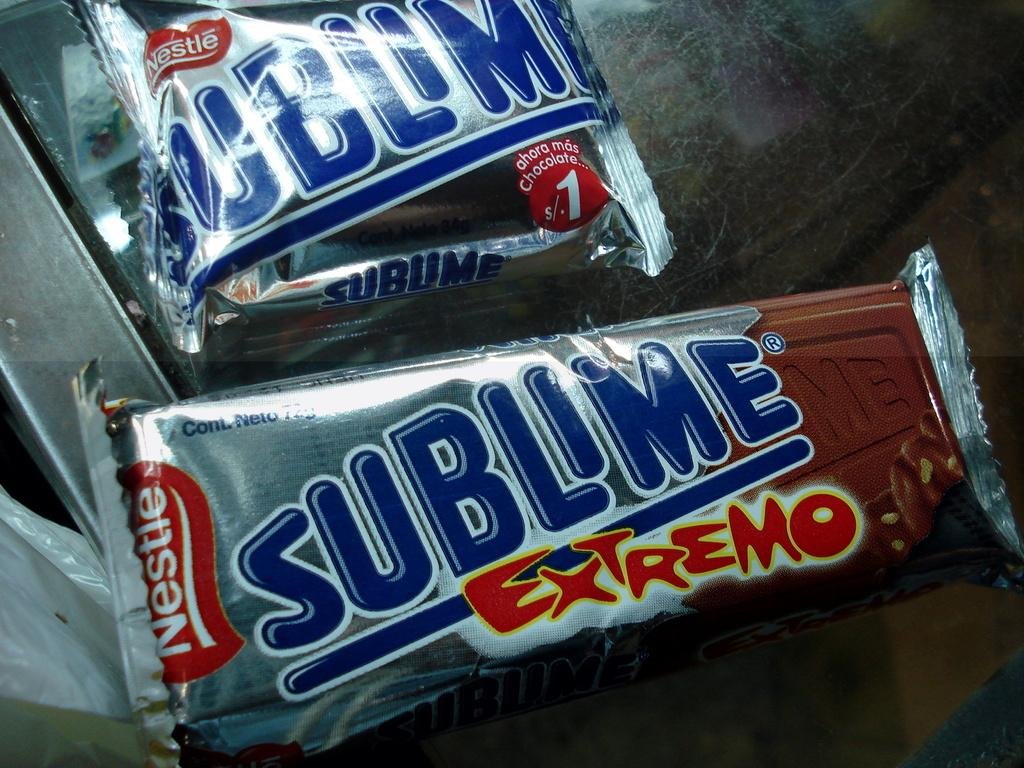<image>
Present a compact description of the photo's key features. two packages of nestle's sublime extremo ice cream 